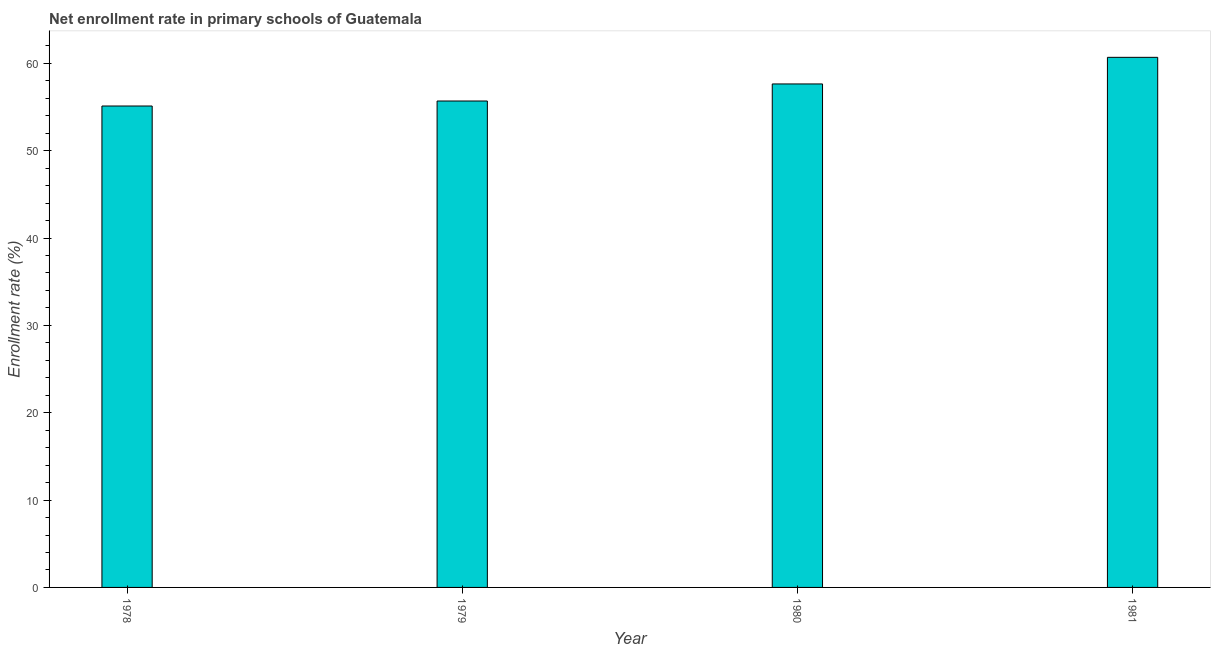Does the graph contain any zero values?
Provide a succinct answer. No. What is the title of the graph?
Your answer should be very brief. Net enrollment rate in primary schools of Guatemala. What is the label or title of the Y-axis?
Provide a short and direct response. Enrollment rate (%). What is the net enrollment rate in primary schools in 1981?
Your answer should be compact. 60.69. Across all years, what is the maximum net enrollment rate in primary schools?
Keep it short and to the point. 60.69. Across all years, what is the minimum net enrollment rate in primary schools?
Your answer should be compact. 55.12. In which year was the net enrollment rate in primary schools minimum?
Your answer should be compact. 1978. What is the sum of the net enrollment rate in primary schools?
Ensure brevity in your answer.  229.14. What is the difference between the net enrollment rate in primary schools in 1978 and 1981?
Offer a terse response. -5.57. What is the average net enrollment rate in primary schools per year?
Give a very brief answer. 57.28. What is the median net enrollment rate in primary schools?
Your answer should be compact. 56.67. In how many years, is the net enrollment rate in primary schools greater than 12 %?
Ensure brevity in your answer.  4. What is the ratio of the net enrollment rate in primary schools in 1979 to that in 1981?
Give a very brief answer. 0.92. Is the net enrollment rate in primary schools in 1980 less than that in 1981?
Offer a very short reply. Yes. Is the difference between the net enrollment rate in primary schools in 1979 and 1981 greater than the difference between any two years?
Keep it short and to the point. No. What is the difference between the highest and the second highest net enrollment rate in primary schools?
Provide a short and direct response. 3.05. Is the sum of the net enrollment rate in primary schools in 1978 and 1981 greater than the maximum net enrollment rate in primary schools across all years?
Offer a terse response. Yes. What is the difference between the highest and the lowest net enrollment rate in primary schools?
Your response must be concise. 5.57. In how many years, is the net enrollment rate in primary schools greater than the average net enrollment rate in primary schools taken over all years?
Offer a terse response. 2. How many bars are there?
Offer a very short reply. 4. Are all the bars in the graph horizontal?
Provide a short and direct response. No. How many years are there in the graph?
Ensure brevity in your answer.  4. Are the values on the major ticks of Y-axis written in scientific E-notation?
Your answer should be very brief. No. What is the Enrollment rate (%) in 1978?
Provide a short and direct response. 55.12. What is the Enrollment rate (%) of 1979?
Your response must be concise. 55.69. What is the Enrollment rate (%) in 1980?
Your answer should be very brief. 57.64. What is the Enrollment rate (%) of 1981?
Provide a succinct answer. 60.69. What is the difference between the Enrollment rate (%) in 1978 and 1979?
Your answer should be compact. -0.57. What is the difference between the Enrollment rate (%) in 1978 and 1980?
Your response must be concise. -2.53. What is the difference between the Enrollment rate (%) in 1978 and 1981?
Give a very brief answer. -5.57. What is the difference between the Enrollment rate (%) in 1979 and 1980?
Your answer should be compact. -1.95. What is the difference between the Enrollment rate (%) in 1979 and 1981?
Keep it short and to the point. -5. What is the difference between the Enrollment rate (%) in 1980 and 1981?
Ensure brevity in your answer.  -3.05. What is the ratio of the Enrollment rate (%) in 1978 to that in 1979?
Make the answer very short. 0.99. What is the ratio of the Enrollment rate (%) in 1978 to that in 1980?
Provide a short and direct response. 0.96. What is the ratio of the Enrollment rate (%) in 1978 to that in 1981?
Keep it short and to the point. 0.91. What is the ratio of the Enrollment rate (%) in 1979 to that in 1981?
Make the answer very short. 0.92. 